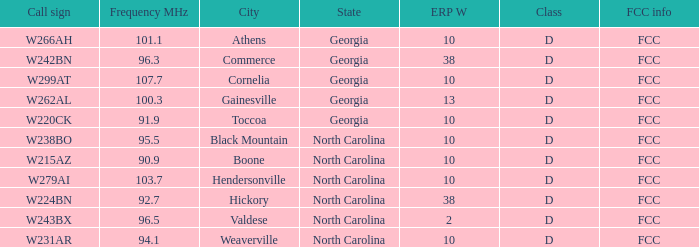What is the Frequency MHz for the station with a call sign of w224bn? 92.7. 